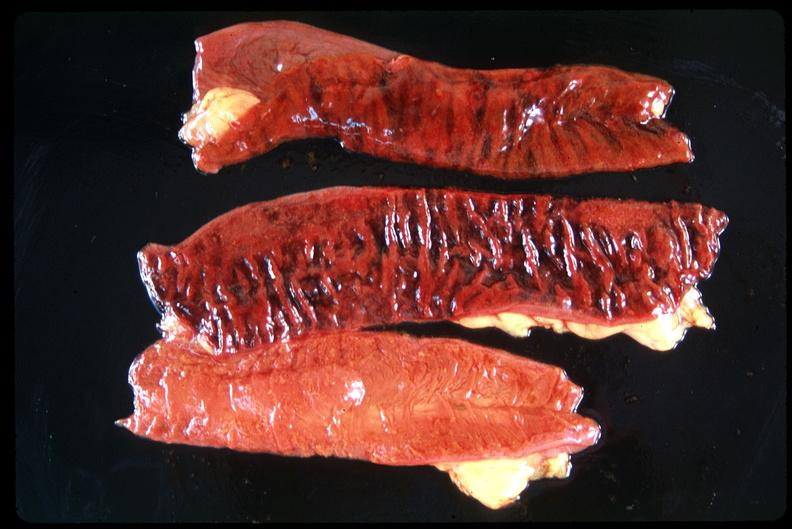s nipple duplication present?
Answer the question using a single word or phrase. No 